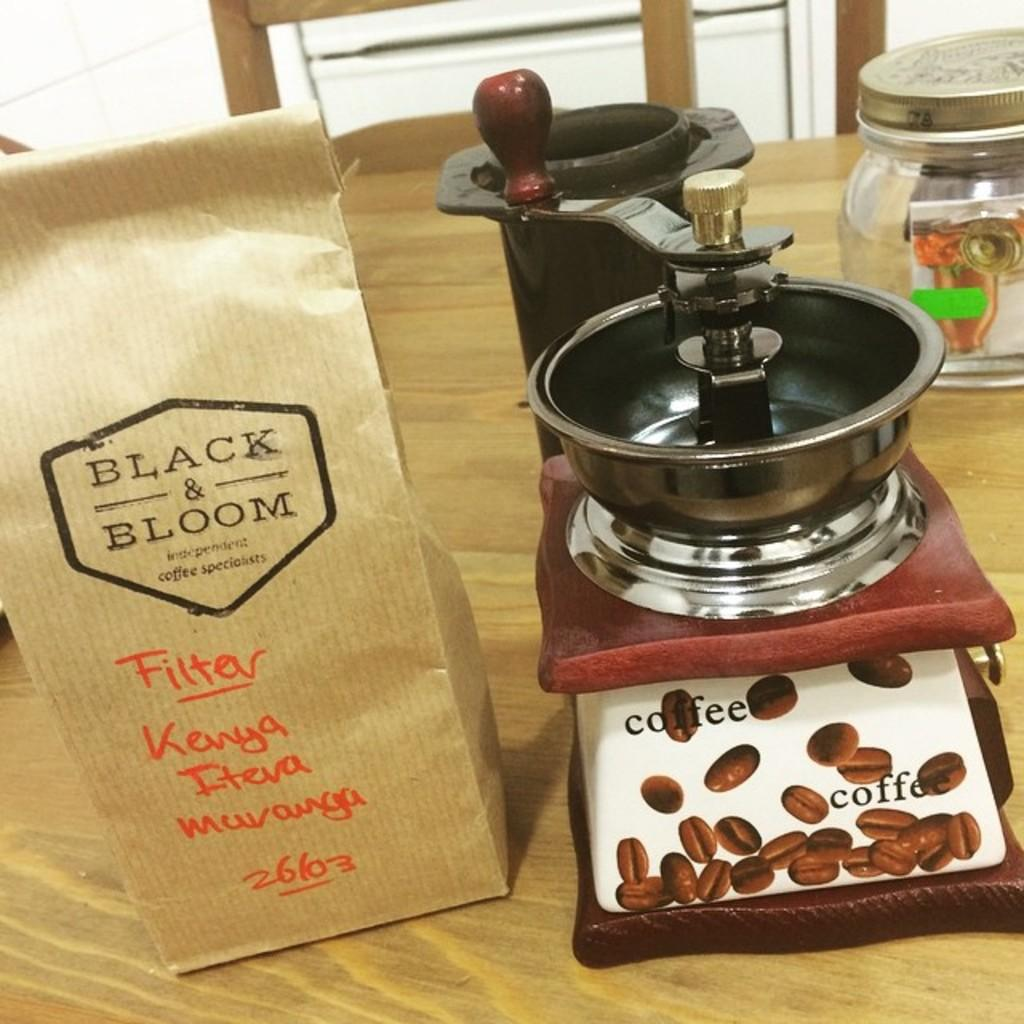<image>
Offer a succinct explanation of the picture presented. A bag from Black and Bloom coffee specialists has been labeled "Filter" and "Kenya". 